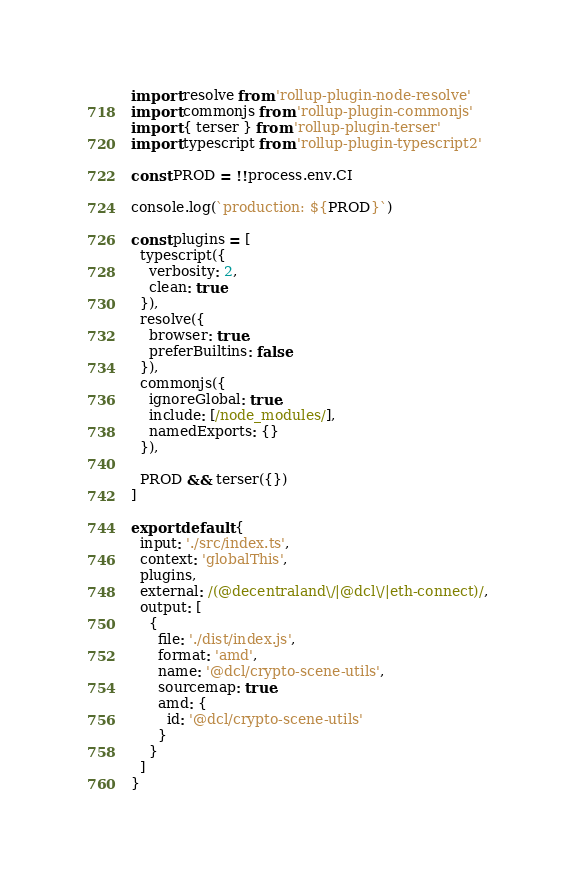<code> <loc_0><loc_0><loc_500><loc_500><_JavaScript_>
import resolve from 'rollup-plugin-node-resolve'
import commonjs from 'rollup-plugin-commonjs'
import { terser } from 'rollup-plugin-terser'
import typescript from 'rollup-plugin-typescript2'

const PROD = !!process.env.CI

console.log(`production: ${PROD}`)

const plugins = [
  typescript({
    verbosity: 2,
    clean: true
  }),
  resolve({
    browser: true,
    preferBuiltins: false
  }),
  commonjs({
    ignoreGlobal: true,
    include: [/node_modules/],
    namedExports: {}
  }),

  PROD && terser({})
]

export default {
  input: './src/index.ts',
  context: 'globalThis',
  plugins,
  external: /(@decentraland\/|@dcl\/|eth-connect)/,
  output: [
    {
      file: './dist/index.js',
      format: 'amd',
      name: '@dcl/crypto-scene-utils',
      sourcemap: true,
      amd: {
        id: '@dcl/crypto-scene-utils'
      }
    }
  ]
}</code> 